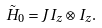<formula> <loc_0><loc_0><loc_500><loc_500>\tilde { H } _ { 0 } = J I _ { z } \otimes I _ { z } .</formula> 